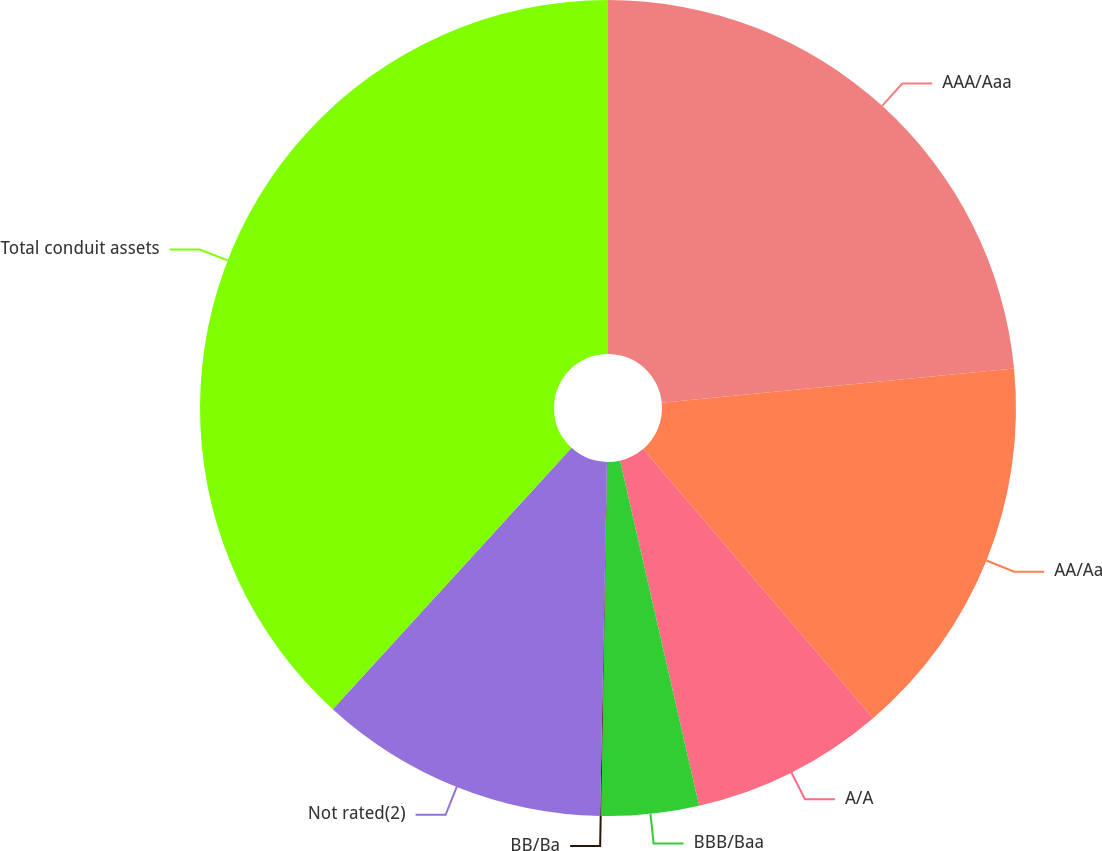Convert chart to OTSL. <chart><loc_0><loc_0><loc_500><loc_500><pie_chart><fcel>AAA/Aaa<fcel>AA/Aa<fcel>A/A<fcel>BBB/Baa<fcel>BB/Ba<fcel>Not rated(2)<fcel>Total conduit assets<nl><fcel>23.45%<fcel>15.29%<fcel>7.67%<fcel>3.85%<fcel>0.04%<fcel>11.48%<fcel>38.21%<nl></chart> 